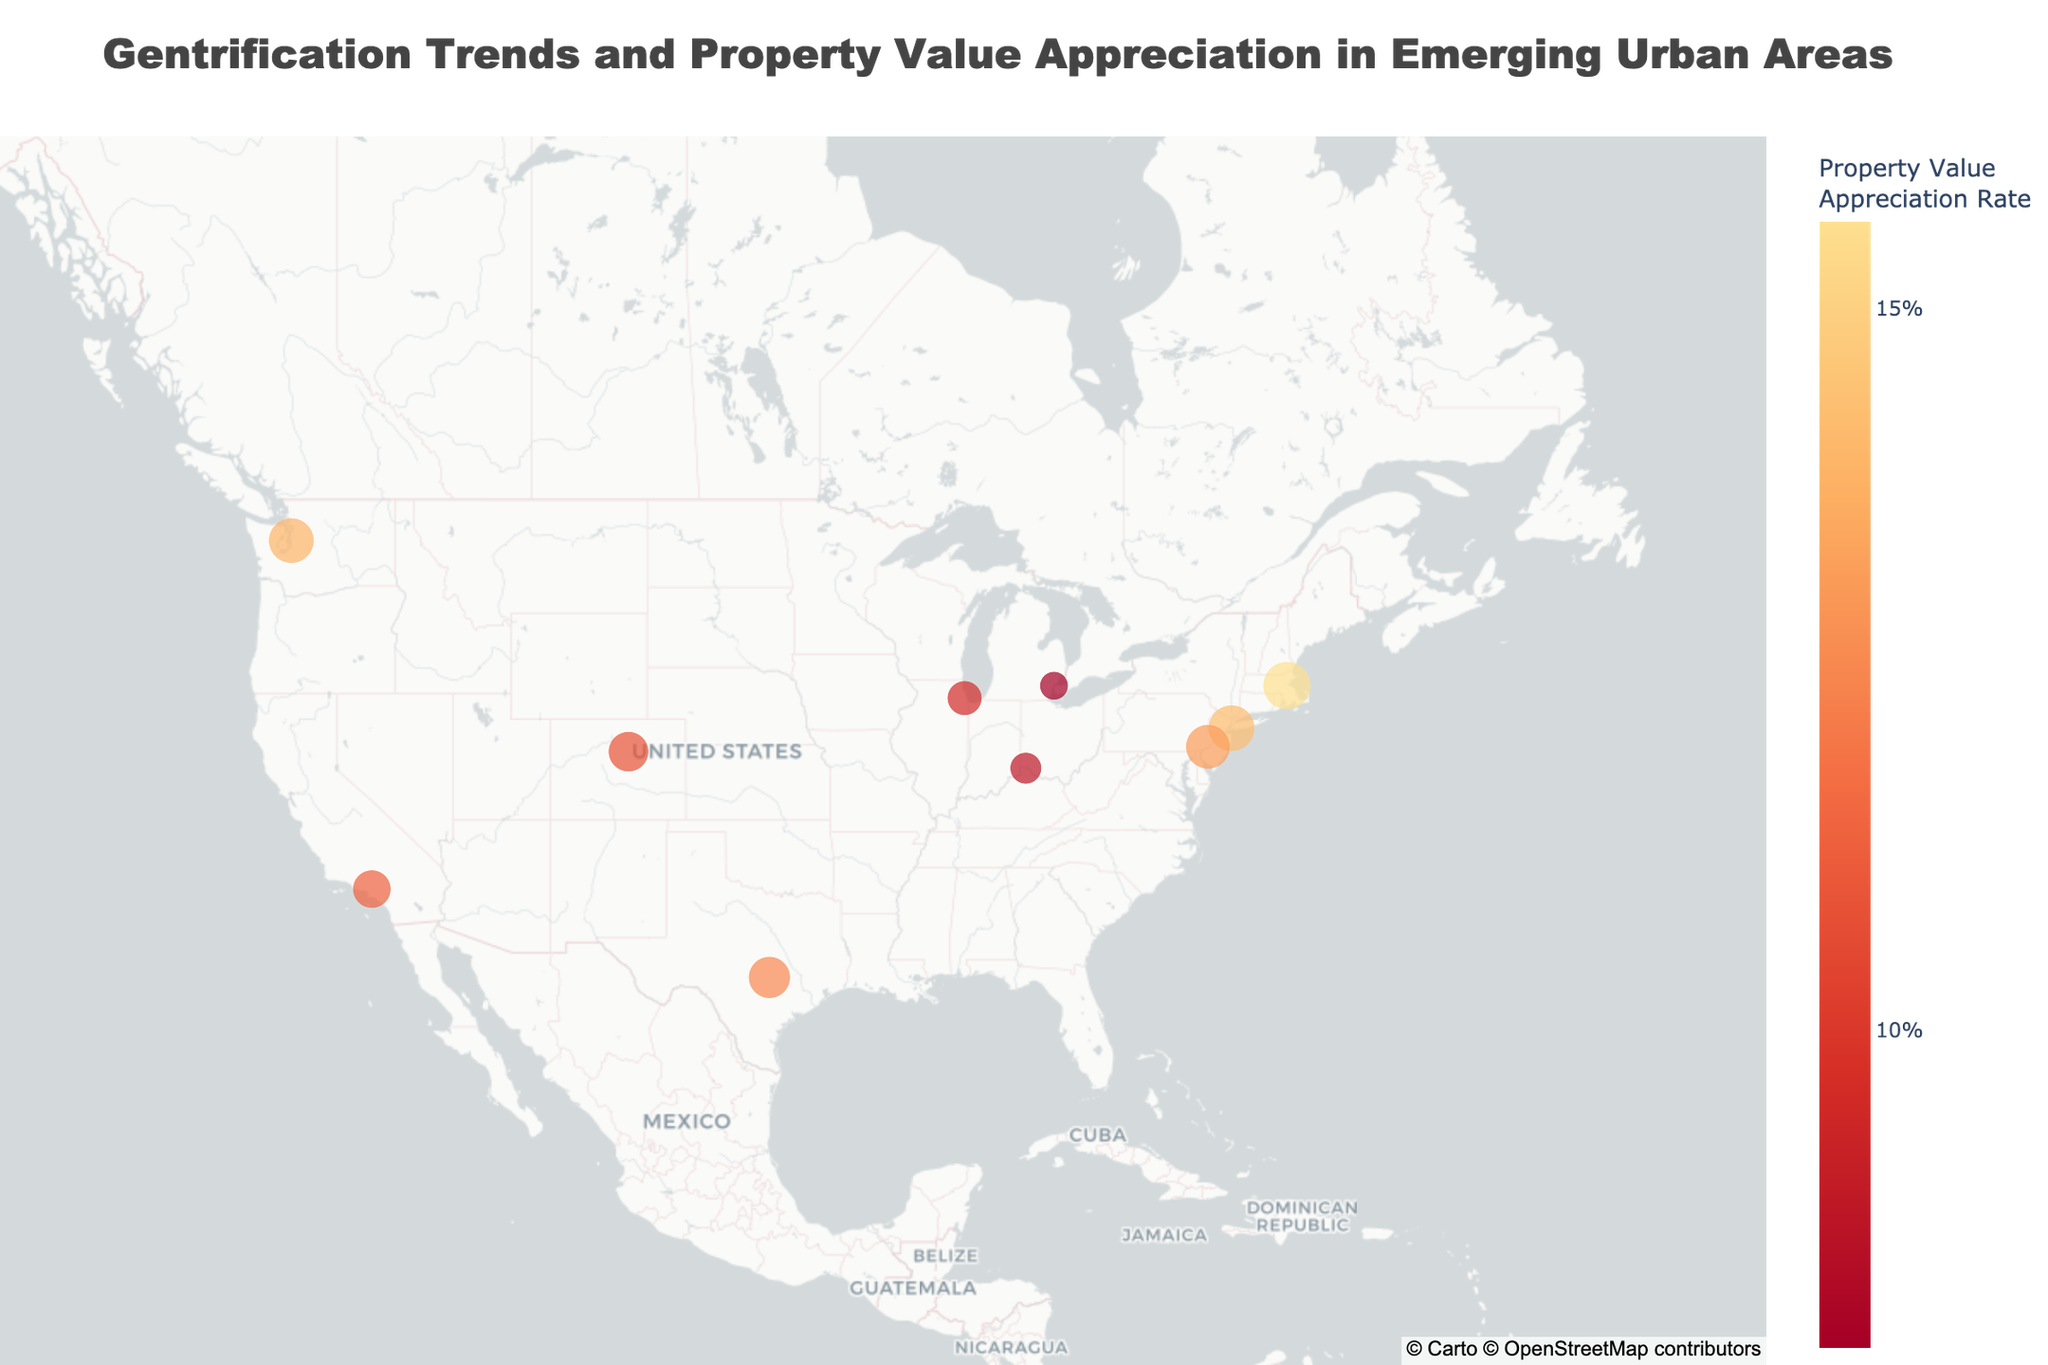What's the title of the figure? The title of the figure is usually situated at the top center. By observing, we see the text presented in a prominent font.
Answer: Gentrification Trends and Property Value Appreciation in Emerging Urban Areas How many neighborhoods are displayed on the map? Each data point on the map represents one neighborhood. Counting the markers from the visual representation gives us the total.
Answer: 10 What is the gentrification index of Bushwick, Brooklyn? By hovering over the marker for Bushwick, Brooklyn, the tooltip displays relevant information, including the gentrification index.
Answer: 9.1 Which neighborhood shows the highest property value appreciation rate? The color scale bar indicates property value appreciation rates. Hovering over respective neighborhoods reveals the rates in the tooltip. The brightest marker signifies the highest rate.
Answer: South End Boston What are the latitudinal and longitudinal coordinates of Corktown, Detroit? Checking the displayed coordinates in the tooltip for Corktown, Detroit marker reveals these values.
Answer: 42.3314, -83.0678 Which neighborhood has the smallest gentrification index, and what is its property value appreciation rate? Hovering over each marker and checking the tooltip helps identify the neighborhood with the lowest gentrification index and its corresponding appreciation rate.
Answer: Corktown Detroit, 7.8% What is the average property value appreciation rate of the neighborhoods displayed? By extracting each neighborhood's property value appreciation rate and calculating their mean: (12.5 + 10.8 + 14.2 + 9.5 + 11.3 + 13.1 + 7.8 + 15.6 + 13.9 + 8.7) / 10
Answer: 11.4% Compare the gentrification index between East Austin and RiNo Denver. Which is higher and by how much? Checking the two gentrification indices, 8.2 for East Austin and 7.9 for RiNo Denver, and then subtracting the two values determines the difference.
Answer: East Austin by 0.3 Which neighborhood is the northernmost based on its latitude? The latitudes are visible in the hover information. Comparing latitudes indicates the northernmost neighborhood, which has the highest latitude.
Answer: Belltown Seattle 